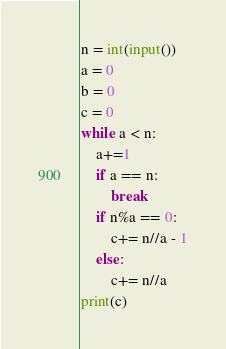Convert code to text. <code><loc_0><loc_0><loc_500><loc_500><_Python_>n = int(input())
a = 0
b = 0
c = 0
while a < n:
    a+=1
    if a == n:
        break
    if n%a == 0:
        c+= n//a - 1
    else:
        c+= n//a
print(c)</code> 